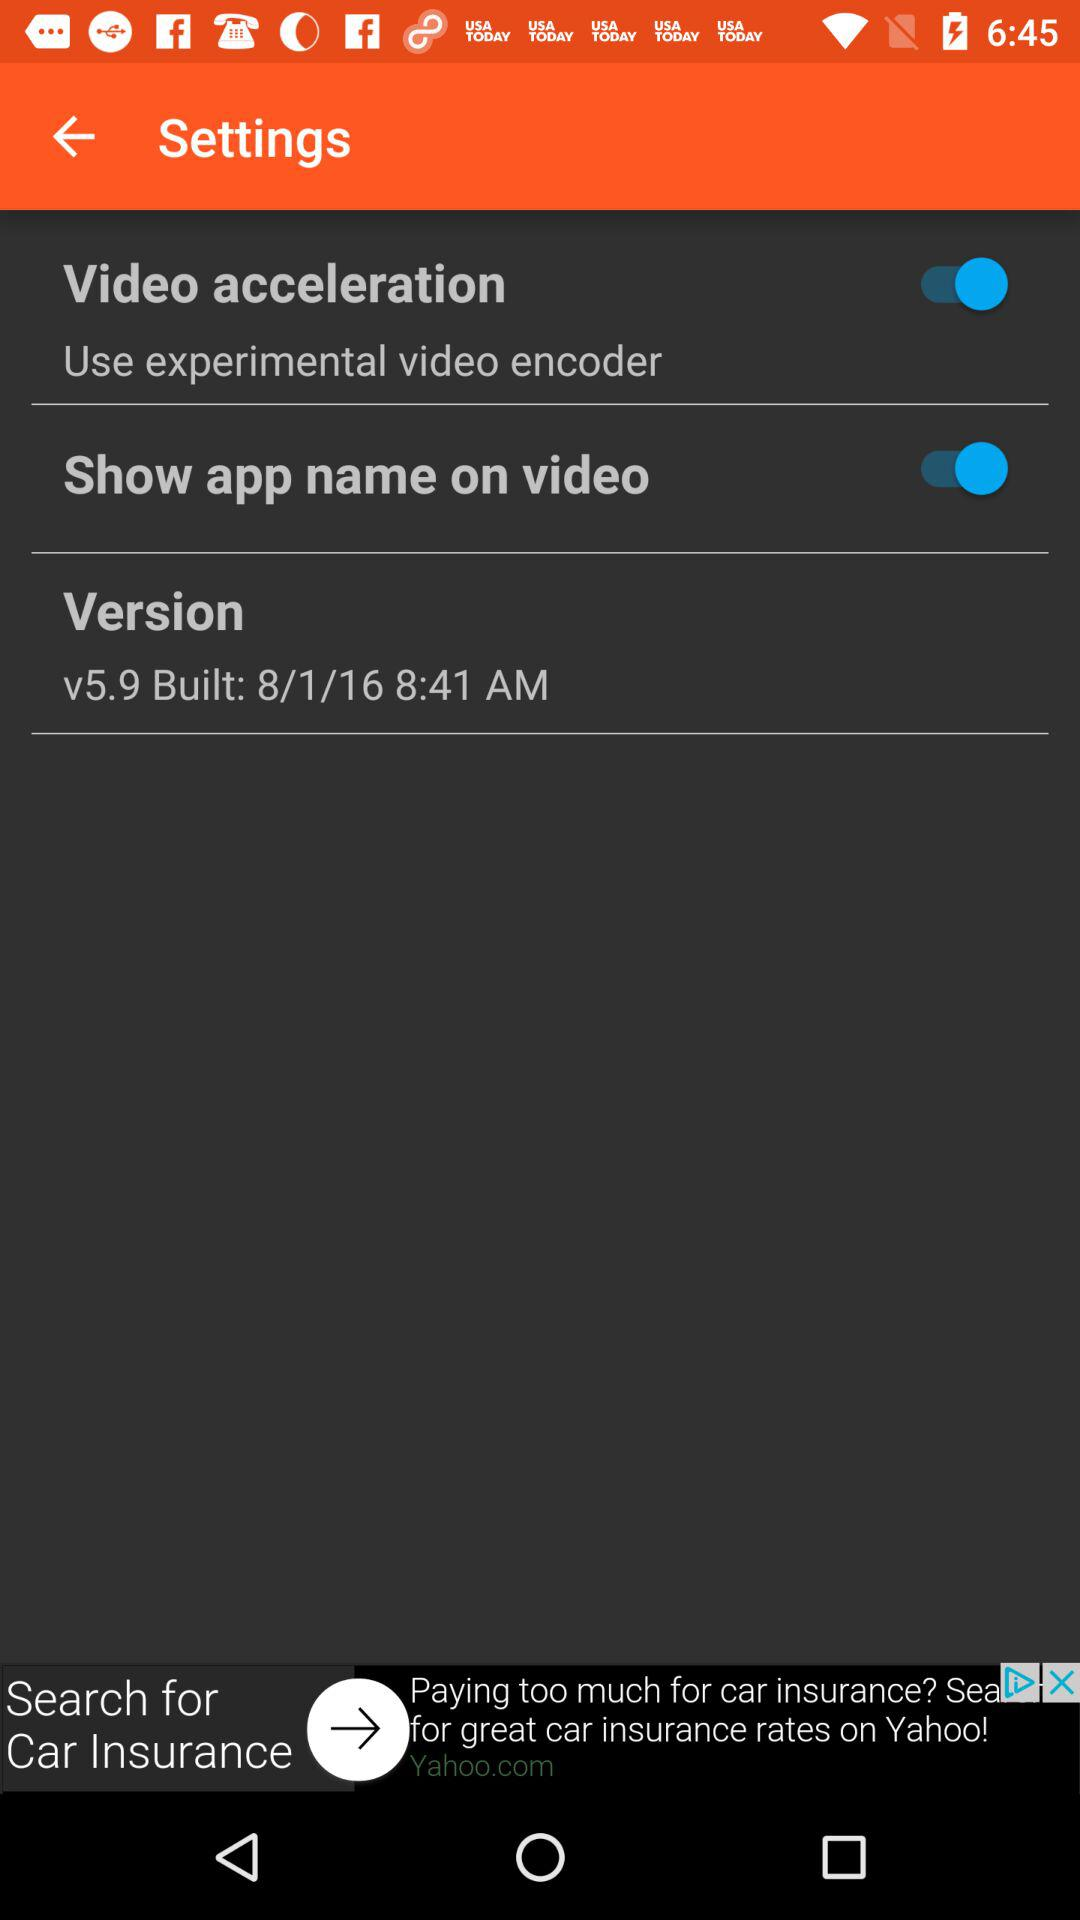What is the status of "Video acceleration"? The status of "Video acceleration" is "on". 